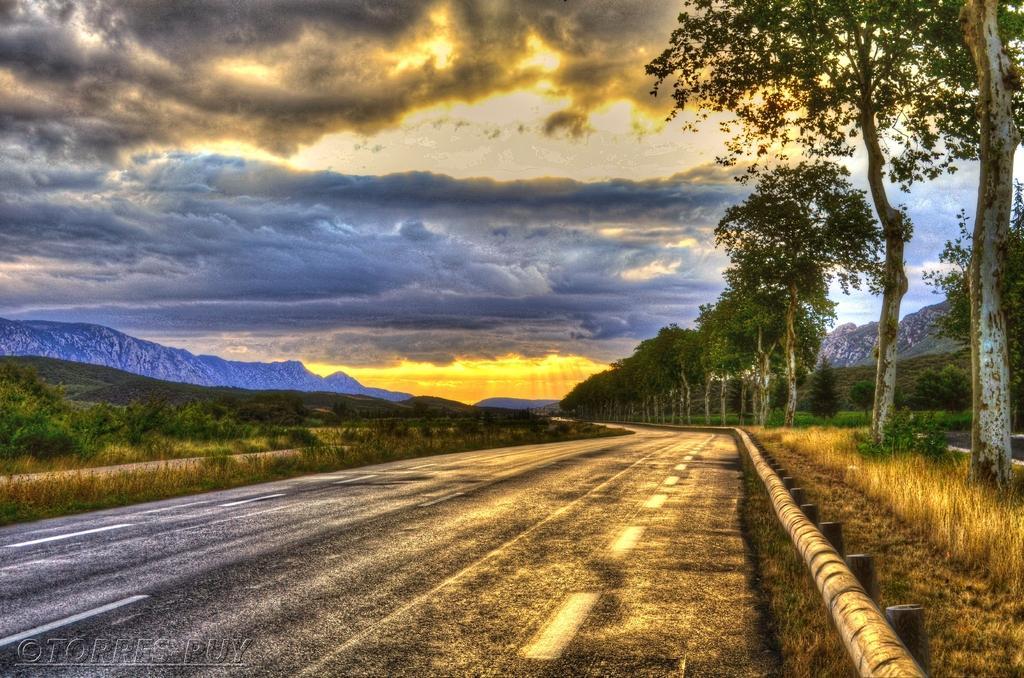Describe this image in one or two sentences. This is an edited picture. In this image there are mountains and trees. At the top there is sky and there are clouds. At the bottom left there is a text. At the bottom there is a road and there is grass and there is a railing on the right side of the image. 